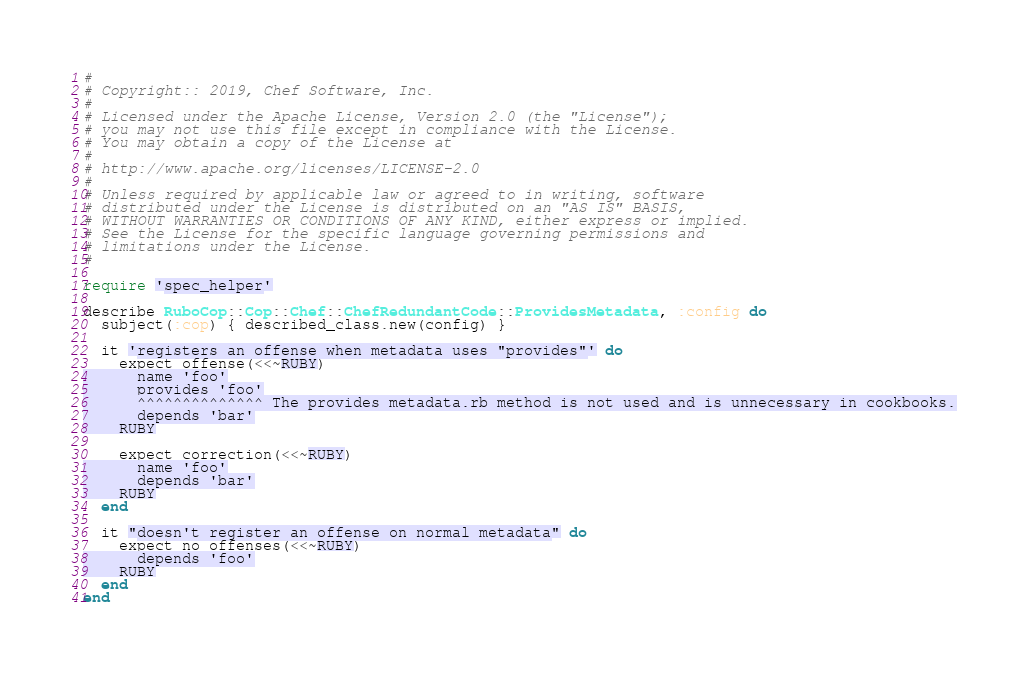<code> <loc_0><loc_0><loc_500><loc_500><_Ruby_>#
# Copyright:: 2019, Chef Software, Inc.
#
# Licensed under the Apache License, Version 2.0 (the "License");
# you may not use this file except in compliance with the License.
# You may obtain a copy of the License at
#
# http://www.apache.org/licenses/LICENSE-2.0
#
# Unless required by applicable law or agreed to in writing, software
# distributed under the License is distributed on an "AS IS" BASIS,
# WITHOUT WARRANTIES OR CONDITIONS OF ANY KIND, either express or implied.
# See the License for the specific language governing permissions and
# limitations under the License.
#

require 'spec_helper'

describe RuboCop::Cop::Chef::ChefRedundantCode::ProvidesMetadata, :config do
  subject(:cop) { described_class.new(config) }

  it 'registers an offense when metadata uses "provides"' do
    expect_offense(<<~RUBY)
      name 'foo'
      provides 'foo'
      ^^^^^^^^^^^^^^ The provides metadata.rb method is not used and is unnecessary in cookbooks.
      depends 'bar'
    RUBY

    expect_correction(<<~RUBY)
      name 'foo'
      depends 'bar'
    RUBY
  end

  it "doesn't register an offense on normal metadata" do
    expect_no_offenses(<<~RUBY)
      depends 'foo'
    RUBY
  end
end
</code> 